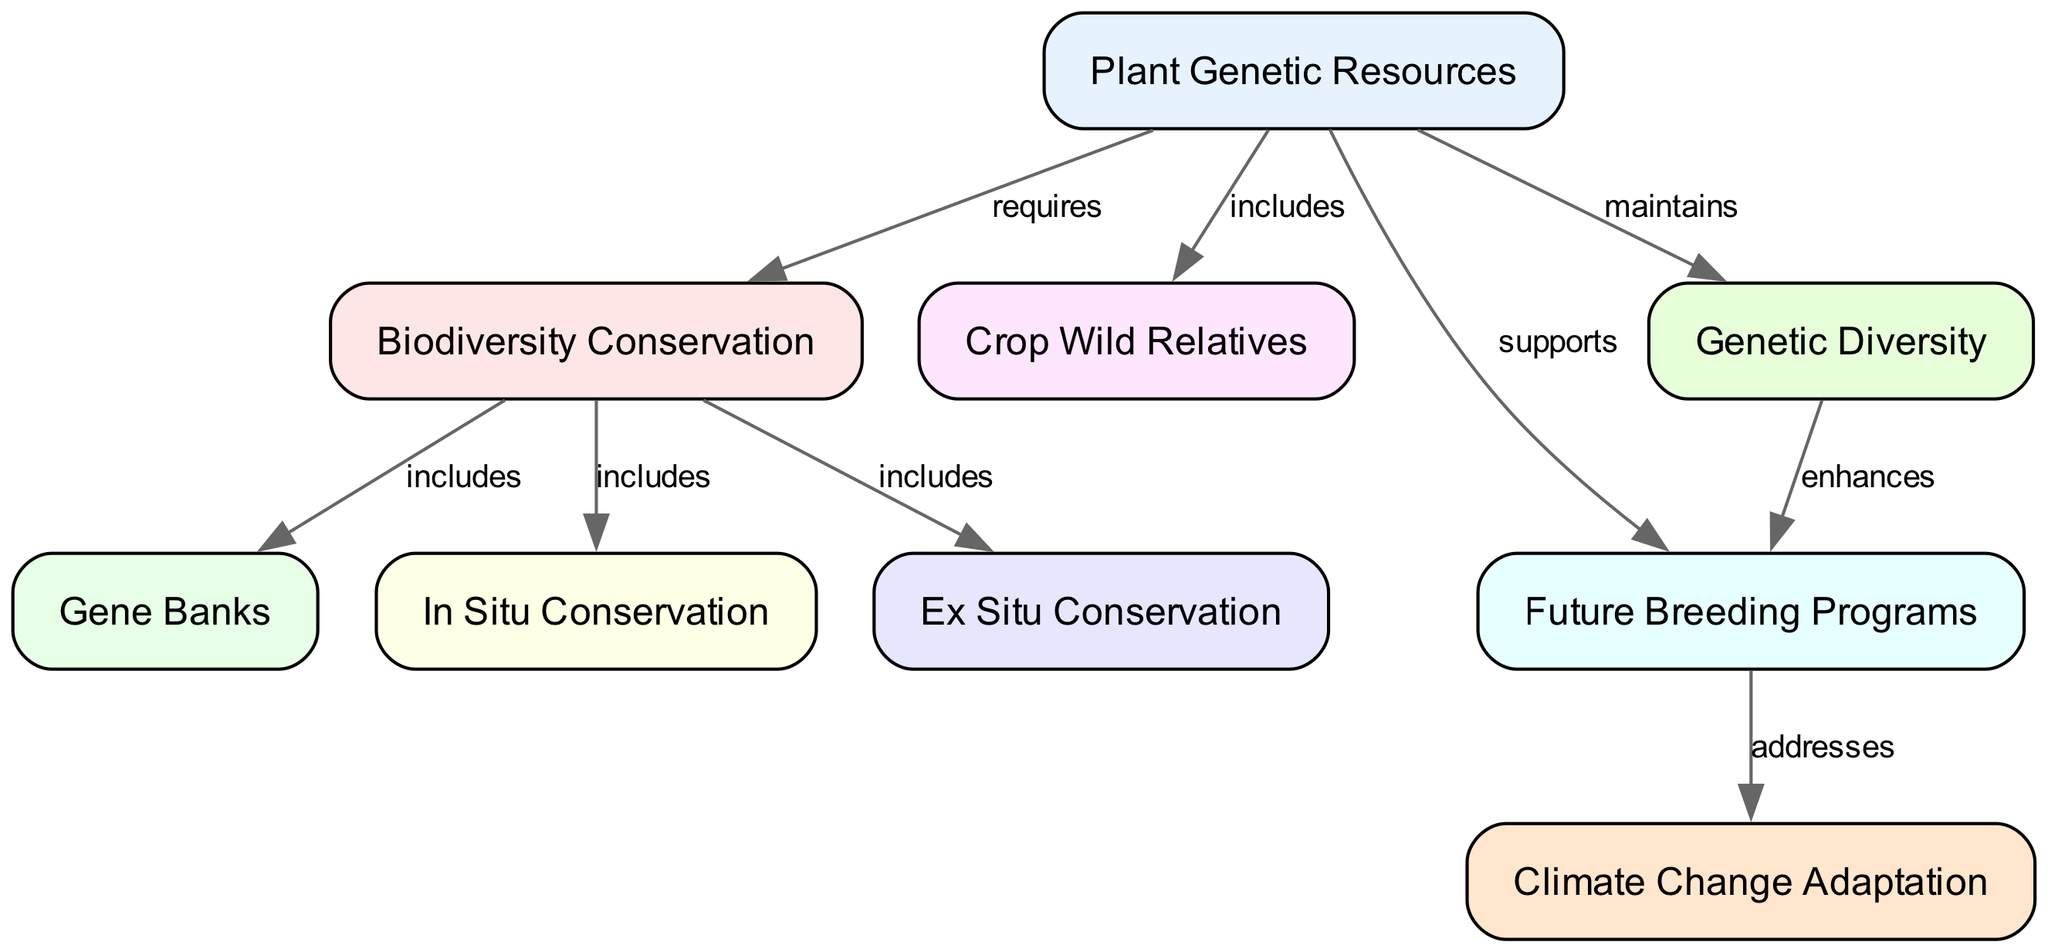What are the three forms of conservation included in biodiversity conservation? From the diagram, the "Biodiversity Conservation" node includes "Gene Banks," "In Situ Conservation," and "Ex Situ Conservation." These connections can be traced through the edges that originate from the "Biodiversity Conservation" node.
Answer: Gene Banks, In Situ Conservation, Ex Situ Conservation How many nodes are present in the diagram? The diagram lists a total of nine distinct nodes that represent various concepts related to plant genetic resources and biodiversity conservation. This can be counted directly from the nodes section of the data.
Answer: 9 What does "Plant Genetic Resources" support? The edge connecting "Plant Genetic Resources" to "Future Breeding Programs" indicates that it supports the future breeding programs. This relationship can be observed directly through the labeled edge in the diagram.
Answer: Future Breeding Programs Which aspect of "Future Breeding Programs" does it address? According to the diagram, "Future Breeding Programs" addresses "Climate Change Adaptation." This is evident from the directed edge that shows the relationship clearly labeled.
Answer: Climate Change Adaptation What do "Plant Genetic Resources" maintain? The diagram shows that "Plant Genetic Resources" maintains "Genetic Diversity." This is established through the directed edge connecting these two nodes.
Answer: Genetic Diversity How does genetic diversity enhance future breeding programs? "Genetic Diversity" enhances "Future Breeding Programs" as indicated by the edge from "Genetic Diversity" to "Future Breeding Programs." This relationship suggests that having a diverse genetic pool allows for better breeding outcomes.
Answer: Enhances 